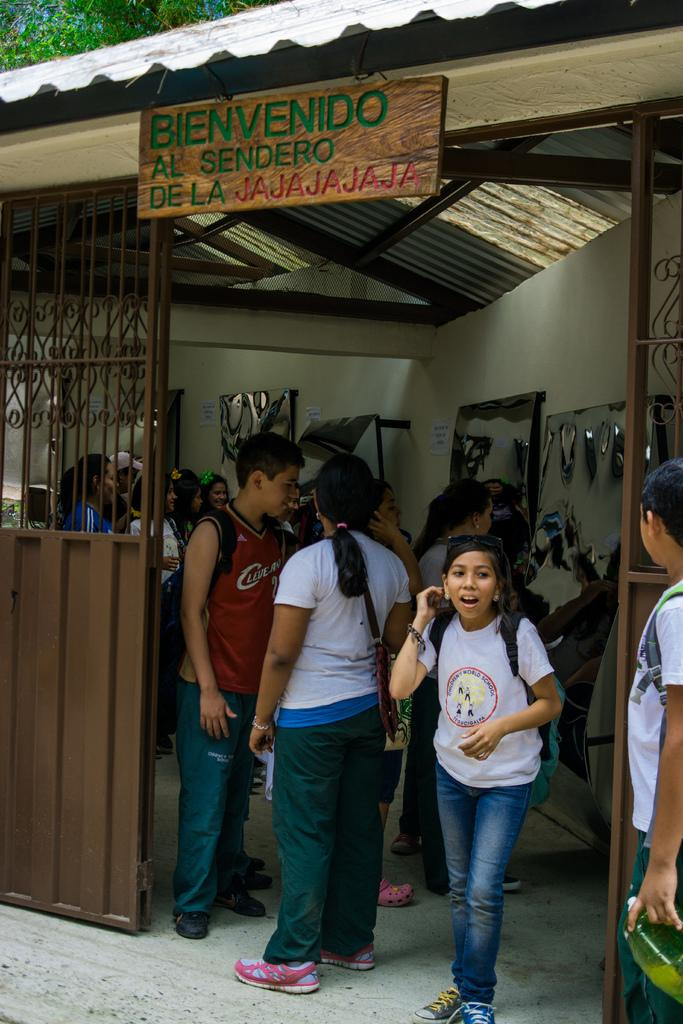Who is present in the image? There are people in the image. Where are the people located? The people are in a shop. What is the shop made of? The shop is covered with iron sheets. What is on top of the shop? There is a board on top of the shop. What can be found on the board? There is text on the board. What type of stone is used to build the roof of the shop? The shop is covered with iron sheets, not stone, so there is no roof made of stone in the image. 